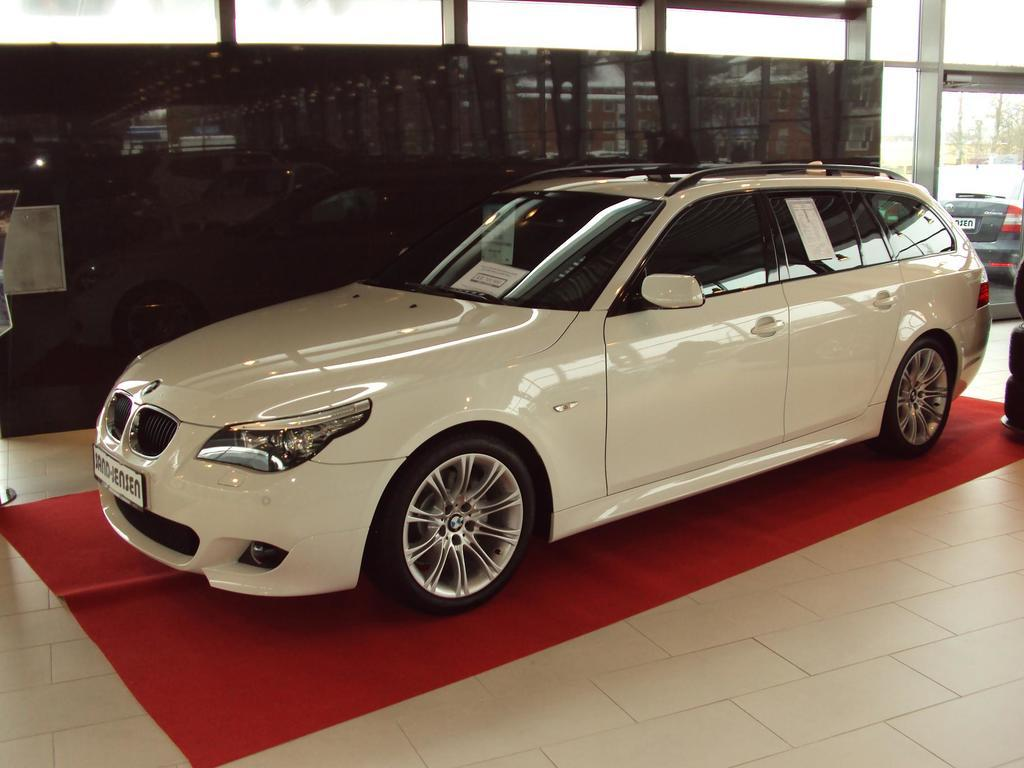What type of vehicles can be seen in the image? There are cars in the image. What is on the floor in the image? There is a mat on the floor in the image. What material is the glass in the image made of? The glass in the image is made of glass. What is reflected in the glass? The glass shows a reflection of vehicles. What can be seen in the background of the image? There are trees and the sky visible in the background of the image. How many snakes are slithering on the mat in the image? There are no snakes present in the image; it only shows cars, a mat, glass, trees, and the sky. What type of wire is used to connect the cars in the image? There is no wire connecting the cars in the image; they are separate vehicles. 